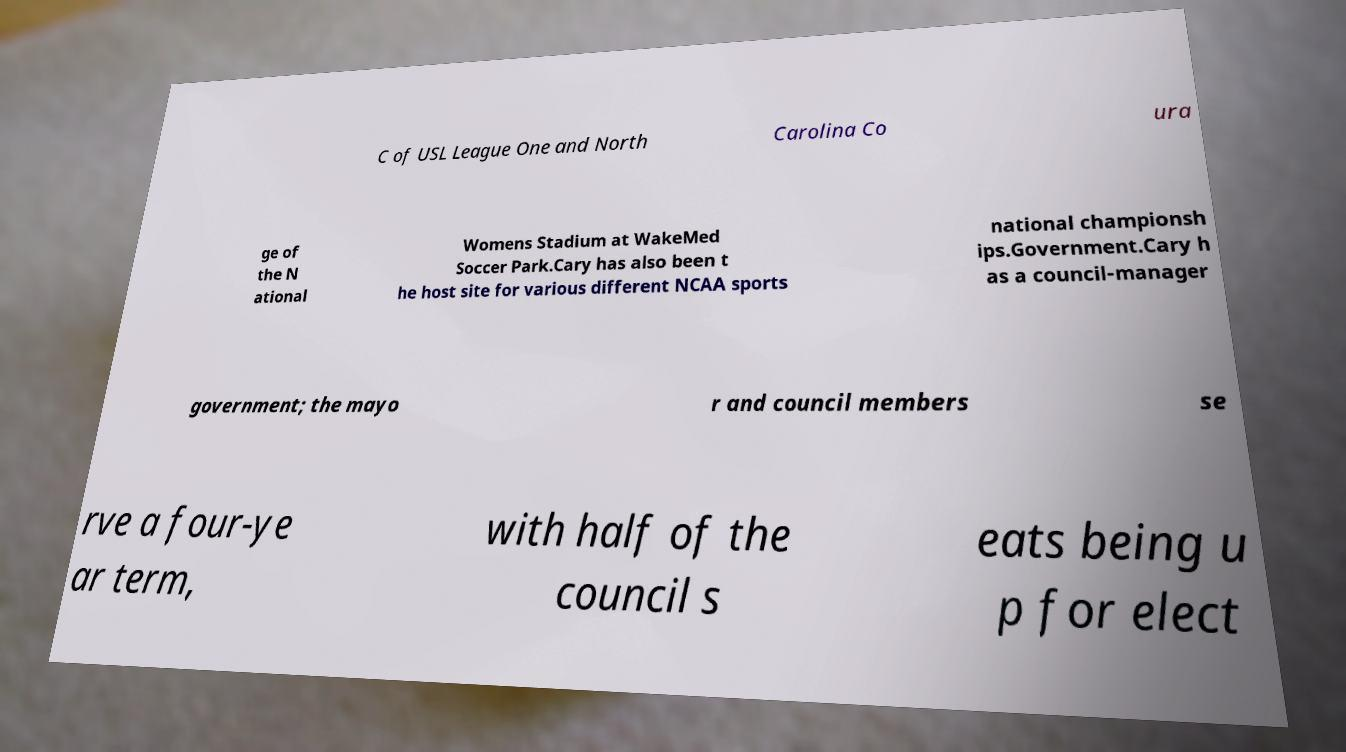Could you extract and type out the text from this image? C of USL League One and North Carolina Co ura ge of the N ational Womens Stadium at WakeMed Soccer Park.Cary has also been t he host site for various different NCAA sports national championsh ips.Government.Cary h as a council-manager government; the mayo r and council members se rve a four-ye ar term, with half of the council s eats being u p for elect 